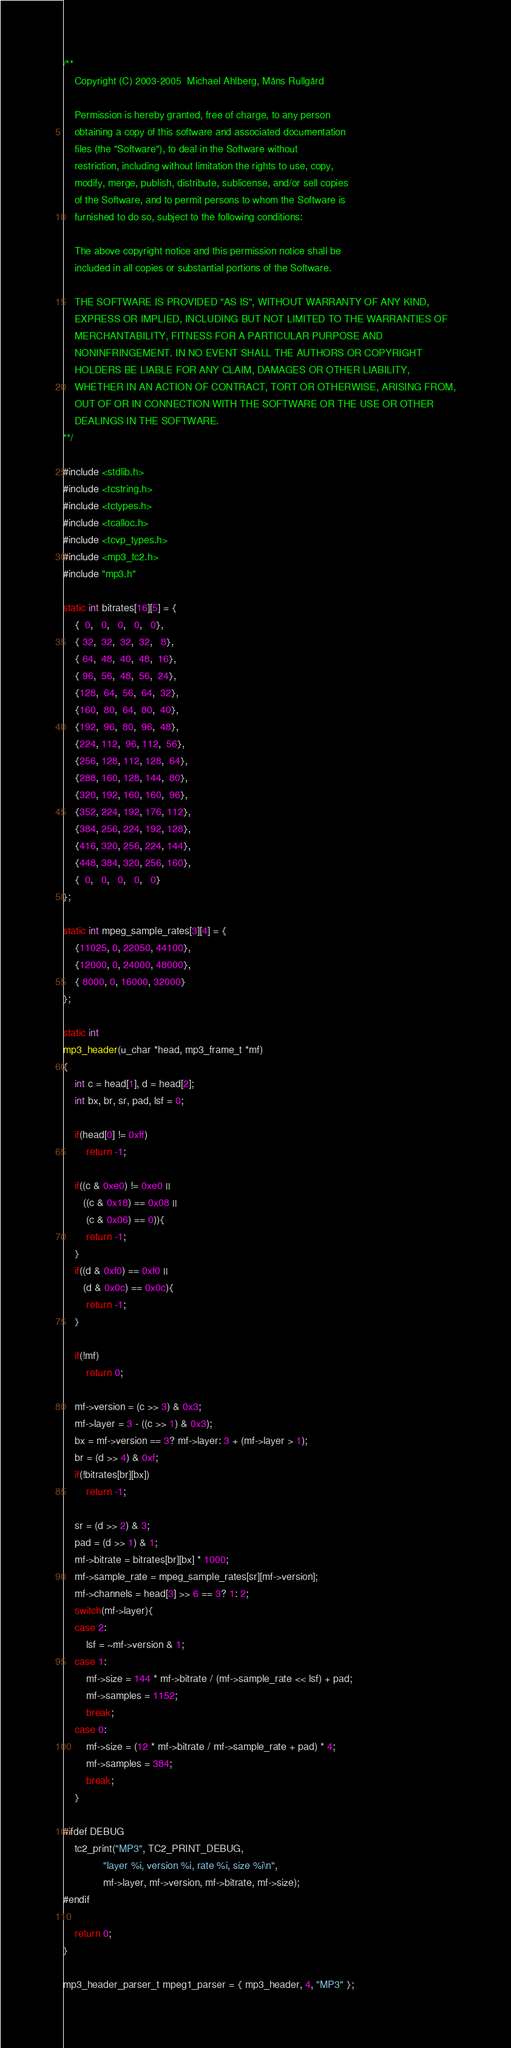Convert code to text. <code><loc_0><loc_0><loc_500><loc_500><_C_>/**
    Copyright (C) 2003-2005  Michael Ahlberg, Måns Rullgård

    Permission is hereby granted, free of charge, to any person
    obtaining a copy of this software and associated documentation
    files (the "Software"), to deal in the Software without
    restriction, including without limitation the rights to use, copy,
    modify, merge, publish, distribute, sublicense, and/or sell copies
    of the Software, and to permit persons to whom the Software is
    furnished to do so, subject to the following conditions:

    The above copyright notice and this permission notice shall be
    included in all copies or substantial portions of the Software.

    THE SOFTWARE IS PROVIDED "AS IS", WITHOUT WARRANTY OF ANY KIND,
    EXPRESS OR IMPLIED, INCLUDING BUT NOT LIMITED TO THE WARRANTIES OF
    MERCHANTABILITY, FITNESS FOR A PARTICULAR PURPOSE AND
    NONINFRINGEMENT. IN NO EVENT SHALL THE AUTHORS OR COPYRIGHT
    HOLDERS BE LIABLE FOR ANY CLAIM, DAMAGES OR OTHER LIABILITY,
    WHETHER IN AN ACTION OF CONTRACT, TORT OR OTHERWISE, ARISING FROM,
    OUT OF OR IN CONNECTION WITH THE SOFTWARE OR THE USE OR OTHER
    DEALINGS IN THE SOFTWARE.
**/

#include <stdlib.h>
#include <tcstring.h>
#include <tctypes.h>
#include <tcalloc.h>
#include <tcvp_types.h>
#include <mp3_tc2.h>
#include "mp3.h"

static int bitrates[16][5] = {
    {  0,   0,   0,   0,   0},
    { 32,  32,  32,  32,   8},
    { 64,  48,  40,  48,  16},
    { 96,  56,  48,  56,  24},
    {128,  64,  56,  64,  32},
    {160,  80,  64,  80,  40},
    {192,  96,  80,  96,  48},
    {224, 112,  96, 112,  56},
    {256, 128, 112, 128,  64},
    {288, 160, 128, 144,  80},
    {320, 192, 160, 160,  96},
    {352, 224, 192, 176, 112},
    {384, 256, 224, 192, 128},
    {416, 320, 256, 224, 144},
    {448, 384, 320, 256, 160},
    {  0,   0,   0,   0,   0}
};

static int mpeg_sample_rates[3][4] = {
    {11025, 0, 22050, 44100},
    {12000, 0, 24000, 48000},
    { 8000, 0, 16000, 32000}
};

static int
mp3_header(u_char *head, mp3_frame_t *mf)
{
    int c = head[1], d = head[2];
    int bx, br, sr, pad, lsf = 0;

    if(head[0] != 0xff)
        return -1;

    if((c & 0xe0) != 0xe0 ||
       ((c & 0x18) == 0x08 ||
        (c & 0x06) == 0)){
        return -1;
    }
    if((d & 0xf0) == 0xf0 ||
       (d & 0x0c) == 0x0c){
        return -1;
    }

    if(!mf)
        return 0;

    mf->version = (c >> 3) & 0x3;
    mf->layer = 3 - ((c >> 1) & 0x3);
    bx = mf->version == 3? mf->layer: 3 + (mf->layer > 1);
    br = (d >> 4) & 0xf;
    if(!bitrates[br][bx])
        return -1;

    sr = (d >> 2) & 3;
    pad = (d >> 1) & 1;
    mf->bitrate = bitrates[br][bx] * 1000;
    mf->sample_rate = mpeg_sample_rates[sr][mf->version];
    mf->channels = head[3] >> 6 == 3? 1: 2;
    switch(mf->layer){
    case 2:
        lsf = ~mf->version & 1;
    case 1:
        mf->size = 144 * mf->bitrate / (mf->sample_rate << lsf) + pad;
        mf->samples = 1152;
        break;
    case 0:
        mf->size = (12 * mf->bitrate / mf->sample_rate + pad) * 4;
        mf->samples = 384;
        break;
    }

#ifdef DEBUG
    tc2_print("MP3", TC2_PRINT_DEBUG,
              "layer %i, version %i, rate %i, size %i\n",
              mf->layer, mf->version, mf->bitrate, mf->size);
#endif

    return 0;
}

mp3_header_parser_t mpeg1_parser = { mp3_header, 4, "MP3" };
</code> 